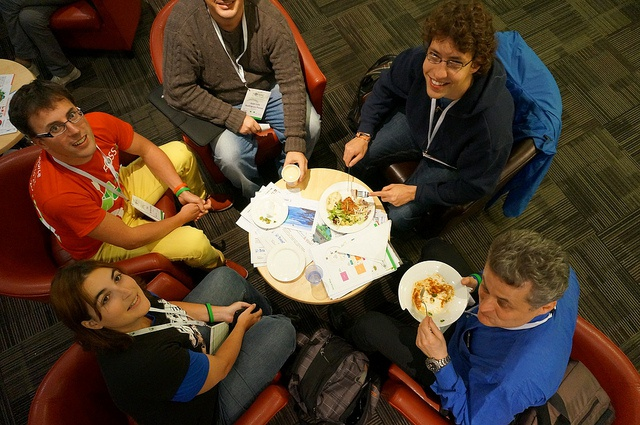Describe the objects in this image and their specific colors. I can see people in black, brown, gray, and maroon tones, people in black, maroon, brown, and tan tones, people in black, brown, and maroon tones, people in black, blue, navy, and olive tones, and people in black, maroon, and gray tones in this image. 